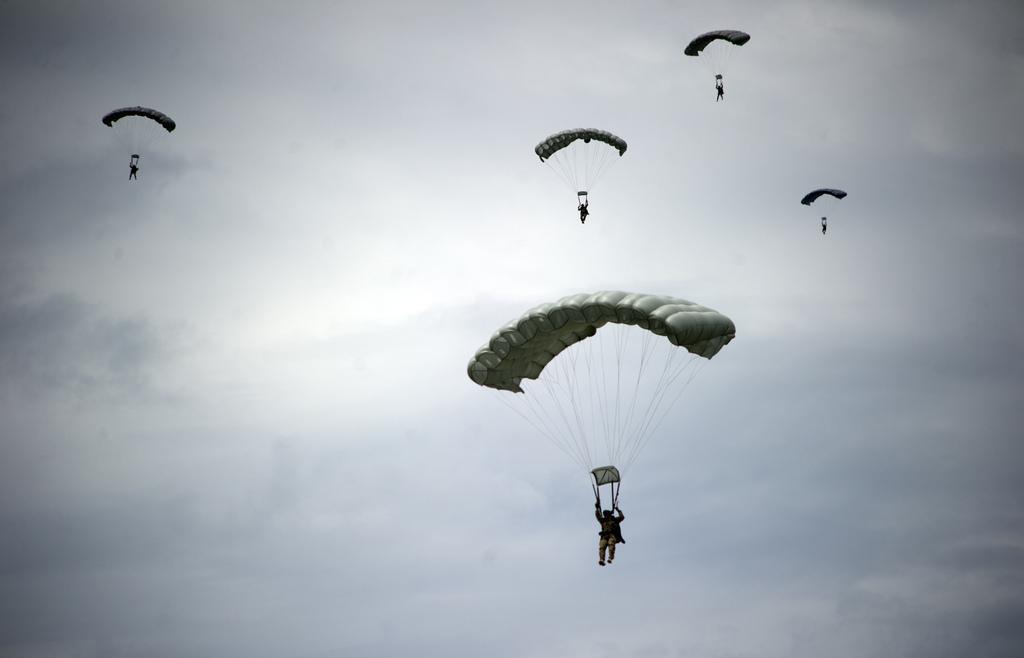Please provide a concise description of this image. This image consists of five flying along with parachutes. In the background, there is sky along with clouds. 